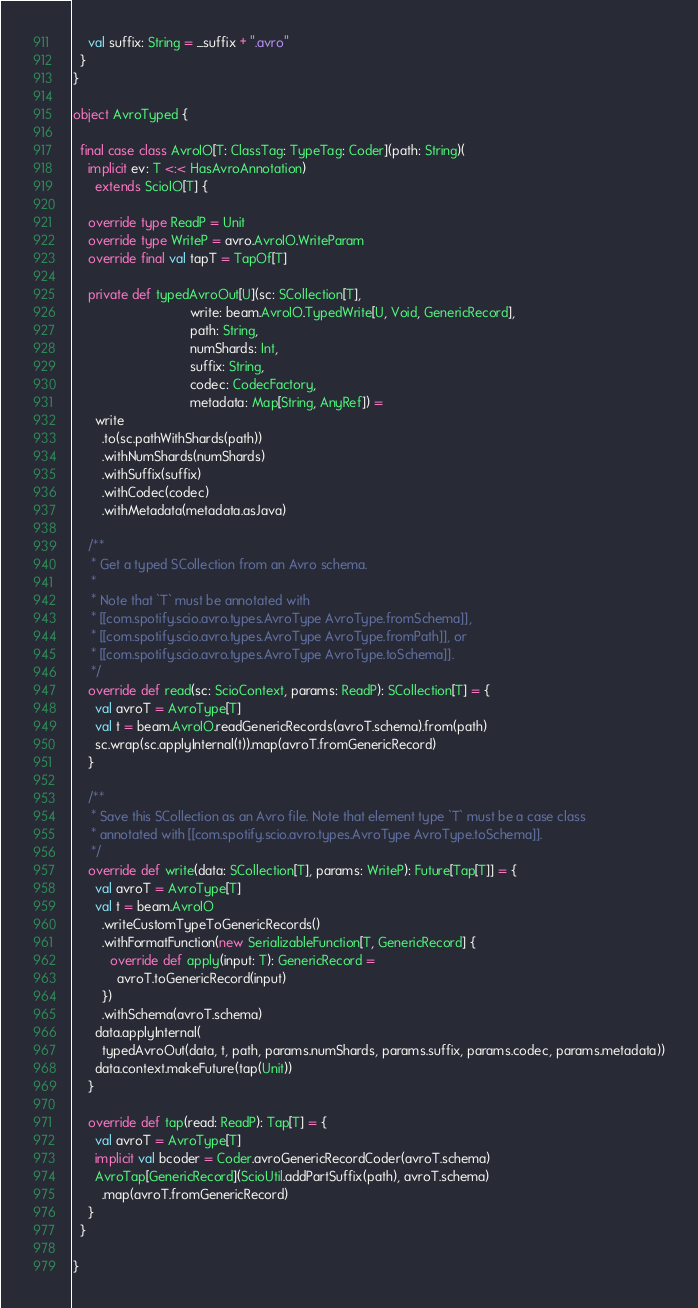<code> <loc_0><loc_0><loc_500><loc_500><_Scala_>    val suffix: String = _suffix + ".avro"
  }
}

object AvroTyped {

  final case class AvroIO[T: ClassTag: TypeTag: Coder](path: String)(
    implicit ev: T <:< HasAvroAnnotation)
      extends ScioIO[T] {

    override type ReadP = Unit
    override type WriteP = avro.AvroIO.WriteParam
    override final val tapT = TapOf[T]

    private def typedAvroOut[U](sc: SCollection[T],
                                write: beam.AvroIO.TypedWrite[U, Void, GenericRecord],
                                path: String,
                                numShards: Int,
                                suffix: String,
                                codec: CodecFactory,
                                metadata: Map[String, AnyRef]) =
      write
        .to(sc.pathWithShards(path))
        .withNumShards(numShards)
        .withSuffix(suffix)
        .withCodec(codec)
        .withMetadata(metadata.asJava)

    /**
     * Get a typed SCollection from an Avro schema.
     *
     * Note that `T` must be annotated with
     * [[com.spotify.scio.avro.types.AvroType AvroType.fromSchema]],
     * [[com.spotify.scio.avro.types.AvroType AvroType.fromPath]], or
     * [[com.spotify.scio.avro.types.AvroType AvroType.toSchema]].
     */
    override def read(sc: ScioContext, params: ReadP): SCollection[T] = {
      val avroT = AvroType[T]
      val t = beam.AvroIO.readGenericRecords(avroT.schema).from(path)
      sc.wrap(sc.applyInternal(t)).map(avroT.fromGenericRecord)
    }

    /**
     * Save this SCollection as an Avro file. Note that element type `T` must be a case class
     * annotated with [[com.spotify.scio.avro.types.AvroType AvroType.toSchema]].
     */
    override def write(data: SCollection[T], params: WriteP): Future[Tap[T]] = {
      val avroT = AvroType[T]
      val t = beam.AvroIO
        .writeCustomTypeToGenericRecords()
        .withFormatFunction(new SerializableFunction[T, GenericRecord] {
          override def apply(input: T): GenericRecord =
            avroT.toGenericRecord(input)
        })
        .withSchema(avroT.schema)
      data.applyInternal(
        typedAvroOut(data, t, path, params.numShards, params.suffix, params.codec, params.metadata))
      data.context.makeFuture(tap(Unit))
    }

    override def tap(read: ReadP): Tap[T] = {
      val avroT = AvroType[T]
      implicit val bcoder = Coder.avroGenericRecordCoder(avroT.schema)
      AvroTap[GenericRecord](ScioUtil.addPartSuffix(path), avroT.schema)
        .map(avroT.fromGenericRecord)
    }
  }

}
</code> 